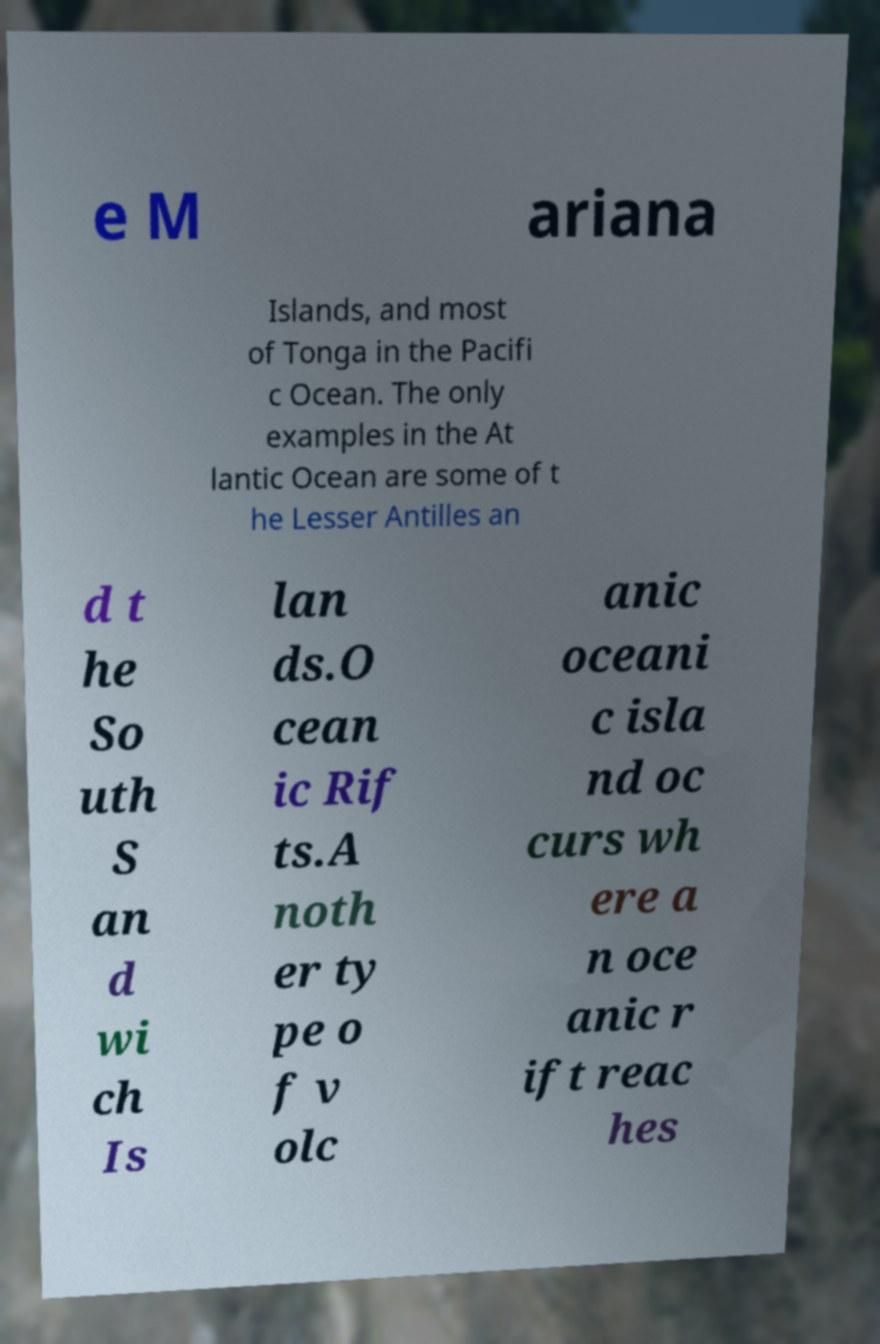Could you extract and type out the text from this image? e M ariana Islands, and most of Tonga in the Pacifi c Ocean. The only examples in the At lantic Ocean are some of t he Lesser Antilles an d t he So uth S an d wi ch Is lan ds.O cean ic Rif ts.A noth er ty pe o f v olc anic oceani c isla nd oc curs wh ere a n oce anic r ift reac hes 